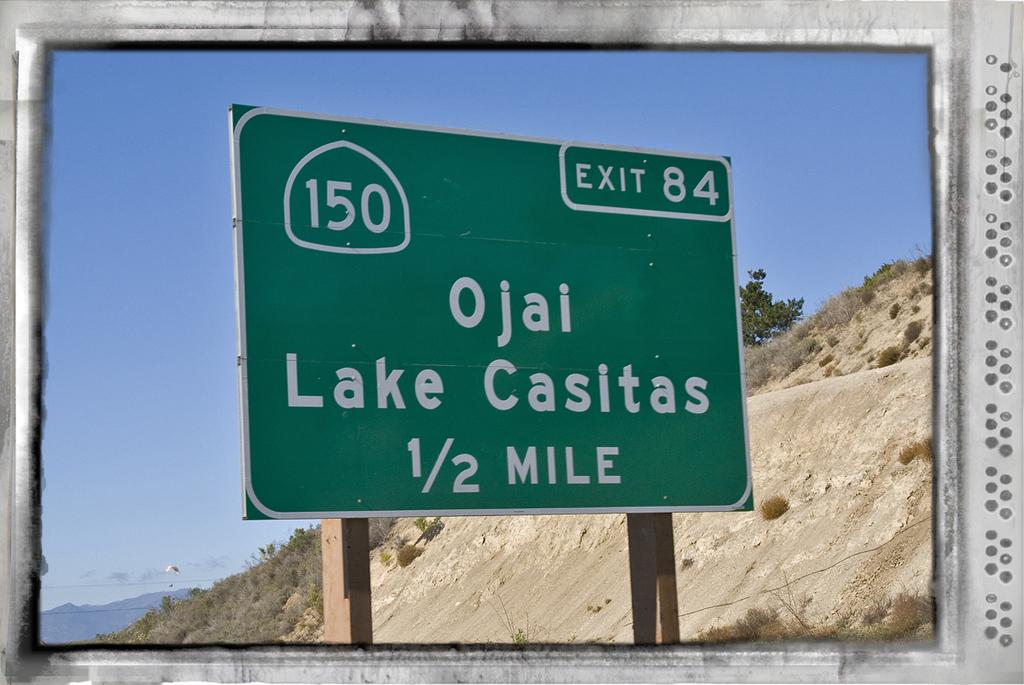<image>
Write a terse but informative summary of the picture. A green sign with the words ojai lake casitas and 150 up top. 